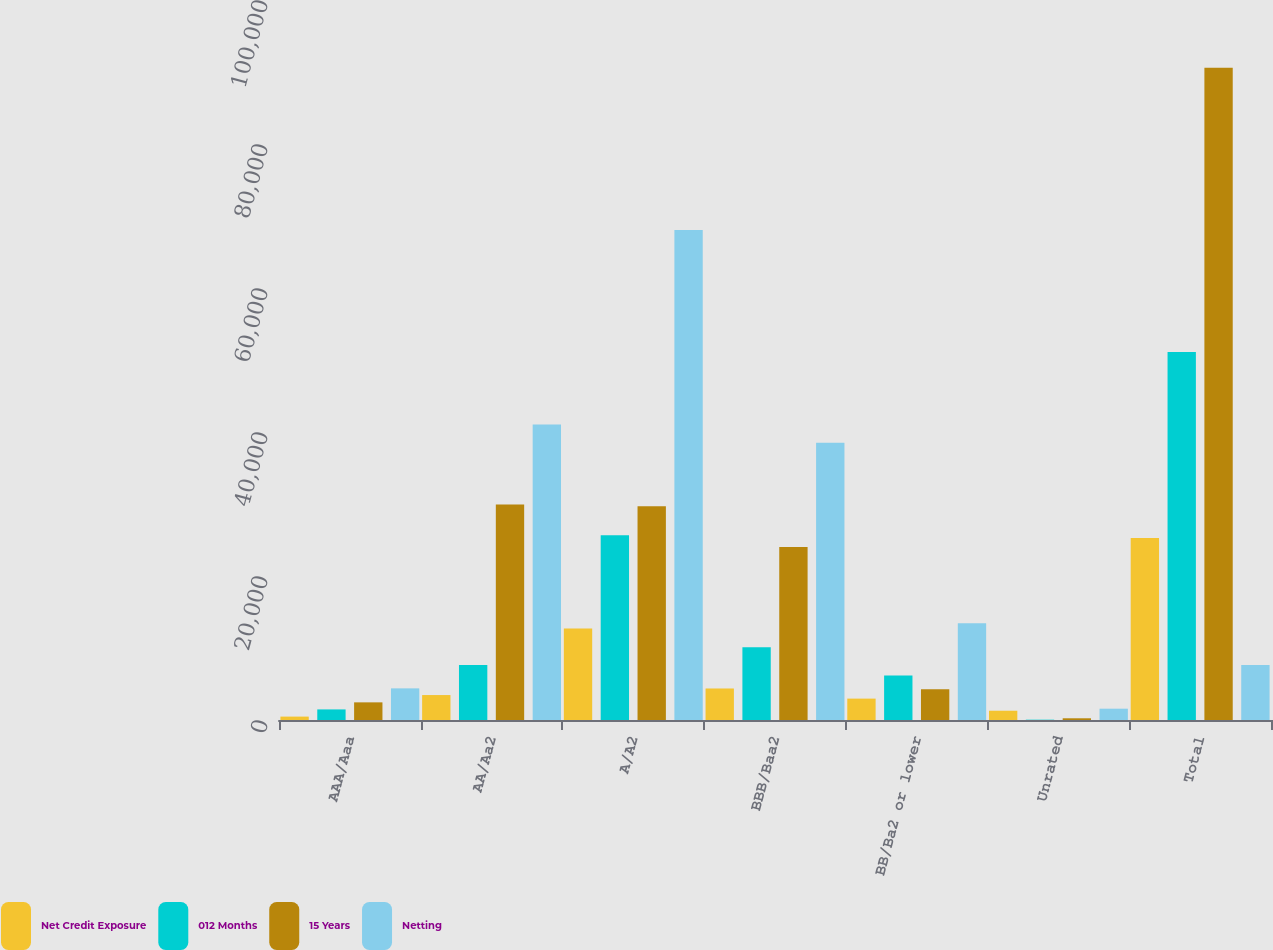Convert chart to OTSL. <chart><loc_0><loc_0><loc_500><loc_500><stacked_bar_chart><ecel><fcel>AAA/Aaa<fcel>AA/Aa2<fcel>A/A2<fcel>BBB/Baa2<fcel>BB/Ba2 or lower<fcel>Unrated<fcel>Total<nl><fcel>Net Credit Exposure<fcel>473<fcel>3463<fcel>12693<fcel>4377<fcel>2972<fcel>1289<fcel>25267<nl><fcel>012 Months<fcel>1470<fcel>7642<fcel>25666<fcel>10112<fcel>6188<fcel>45<fcel>51123<nl><fcel>15 Years<fcel>2450<fcel>29926<fcel>29701<fcel>24013<fcel>4271<fcel>238<fcel>90599<nl><fcel>Netting<fcel>4393<fcel>41031<fcel>68060<fcel>38502<fcel>13431<fcel>1572<fcel>7642<nl></chart> 